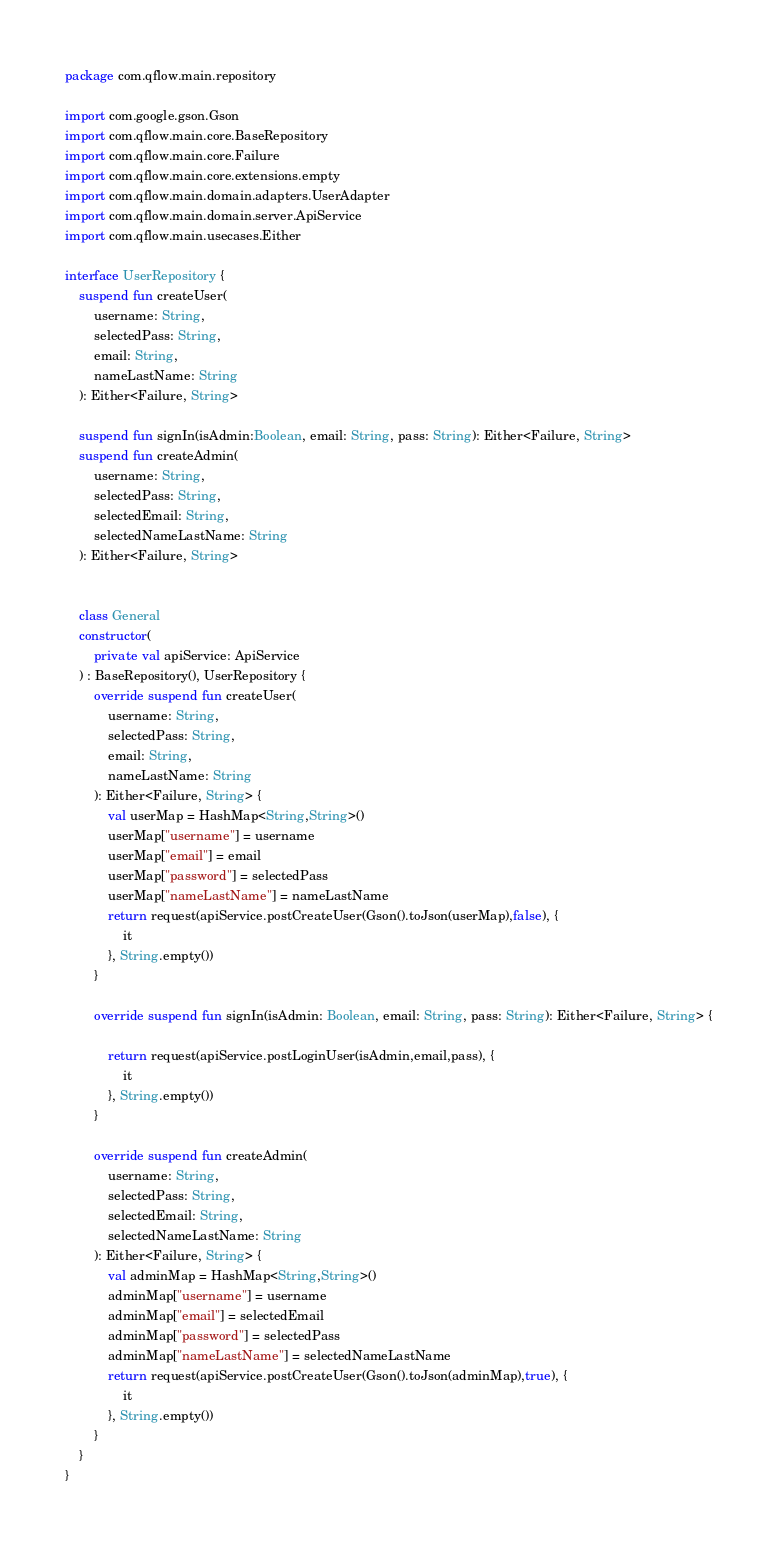Convert code to text. <code><loc_0><loc_0><loc_500><loc_500><_Kotlin_>package com.qflow.main.repository

import com.google.gson.Gson
import com.qflow.main.core.BaseRepository
import com.qflow.main.core.Failure
import com.qflow.main.core.extensions.empty
import com.qflow.main.domain.adapters.UserAdapter
import com.qflow.main.domain.server.ApiService
import com.qflow.main.usecases.Either

interface UserRepository {
    suspend fun createUser(
        username: String,
        selectedPass: String,
        email: String,
        nameLastName: String
    ): Either<Failure, String>

    suspend fun signIn(isAdmin:Boolean, email: String, pass: String): Either<Failure, String>
    suspend fun createAdmin(
        username: String,
        selectedPass: String,
        selectedEmail: String,
        selectedNameLastName: String
    ): Either<Failure, String>


    class General
    constructor(
        private val apiService: ApiService
    ) : BaseRepository(), UserRepository {
        override suspend fun createUser(
            username: String,
            selectedPass: String,
            email: String,
            nameLastName: String
        ): Either<Failure, String> {
            val userMap = HashMap<String,String>()
            userMap["username"] = username
            userMap["email"] = email
            userMap["password"] = selectedPass
            userMap["nameLastName"] = nameLastName
            return request(apiService.postCreateUser(Gson().toJson(userMap),false), {
                it
            }, String.empty())
        }

        override suspend fun signIn(isAdmin: Boolean, email: String, pass: String): Either<Failure, String> {

            return request(apiService.postLoginUser(isAdmin,email,pass), {
                it
            }, String.empty())
        }

        override suspend fun createAdmin(
            username: String,
            selectedPass: String,
            selectedEmail: String,
            selectedNameLastName: String
        ): Either<Failure, String> {
            val adminMap = HashMap<String,String>()
            adminMap["username"] = username
            adminMap["email"] = selectedEmail
            adminMap["password"] = selectedPass
            adminMap["nameLastName"] = selectedNameLastName
            return request(apiService.postCreateUser(Gson().toJson(adminMap),true), {
                it
            }, String.empty())
        }
    }
}</code> 